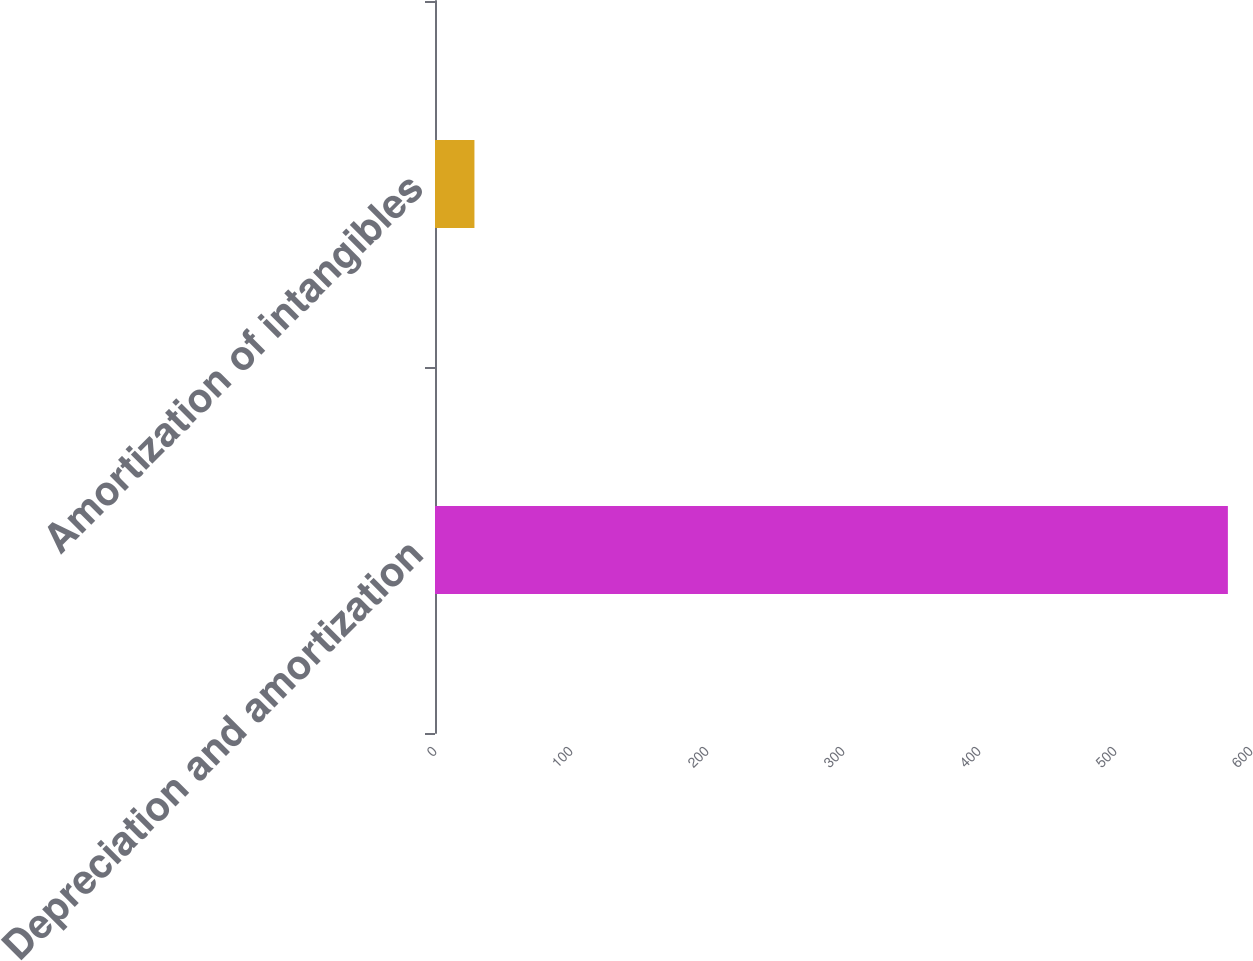Convert chart. <chart><loc_0><loc_0><loc_500><loc_500><bar_chart><fcel>Depreciation and amortization<fcel>Amortization of intangibles<nl><fcel>583<fcel>29<nl></chart> 